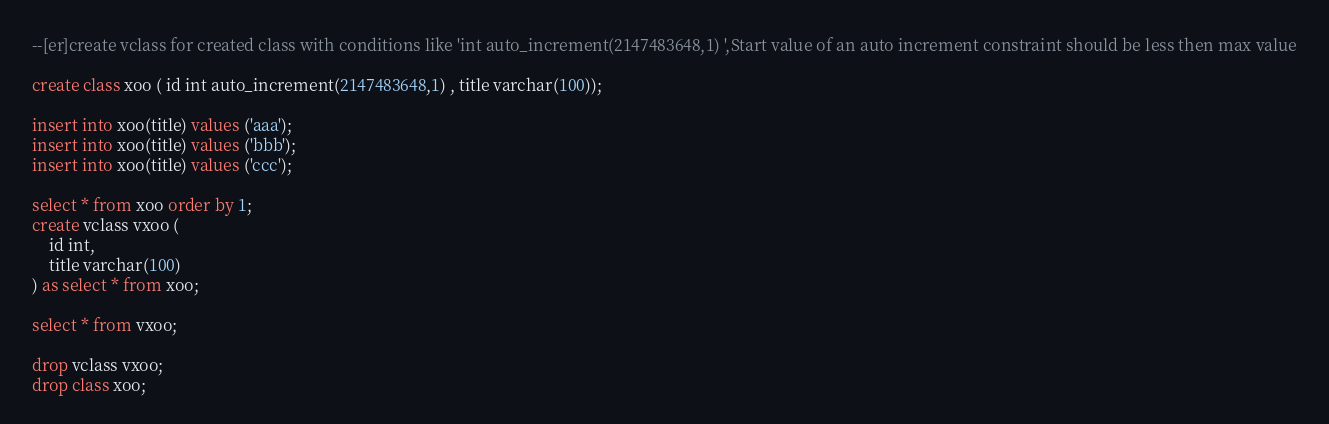<code> <loc_0><loc_0><loc_500><loc_500><_SQL_>--[er]create vclass for created class with conditions like 'int auto_increment(2147483648,1) ',Start value of an auto increment constraint should be less then max value

create class xoo ( id int auto_increment(2147483648,1) , title varchar(100));

insert into xoo(title) values ('aaa');
insert into xoo(title) values ('bbb');
insert into xoo(title) values ('ccc');

select * from xoo order by 1;
create vclass vxoo (
	id int, 
	title varchar(100)
) as select * from xoo;

select * from vxoo;

drop vclass vxoo;
drop class xoo;</code> 